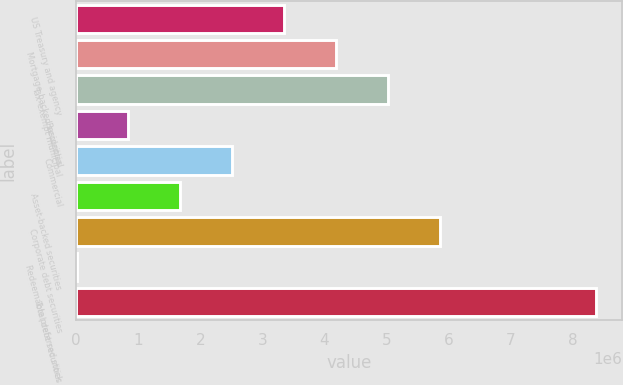Convert chart. <chart><loc_0><loc_0><loc_500><loc_500><bar_chart><fcel>US Treasury and agency<fcel>Mortgage-backed securities<fcel>Tax-exempt municipal<fcel>Residential<fcel>Commercial<fcel>Asset-backed securities<fcel>Corporate debt securities<fcel>Redeemable preferred stock<fcel>Total debt securities<nl><fcel>3.35218e+06<fcel>4.18889e+06<fcel>5.0256e+06<fcel>842044<fcel>2.51546e+06<fcel>1.67875e+06<fcel>5.86231e+06<fcel>5333<fcel>8.37244e+06<nl></chart> 